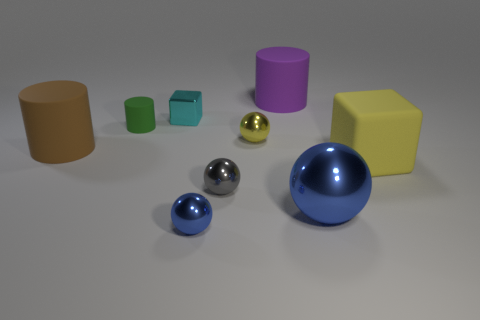Subtract all green cylinders. How many blue balls are left? 2 Subtract all big brown cylinders. How many cylinders are left? 2 Subtract 1 balls. How many balls are left? 3 Subtract all yellow balls. How many balls are left? 3 Subtract all spheres. How many objects are left? 5 Add 1 big yellow metallic cubes. How many big yellow metallic cubes exist? 1 Subtract 0 blue blocks. How many objects are left? 9 Subtract all green balls. Subtract all red cylinders. How many balls are left? 4 Subtract all large brown cylinders. Subtract all large purple cylinders. How many objects are left? 7 Add 3 green cylinders. How many green cylinders are left? 4 